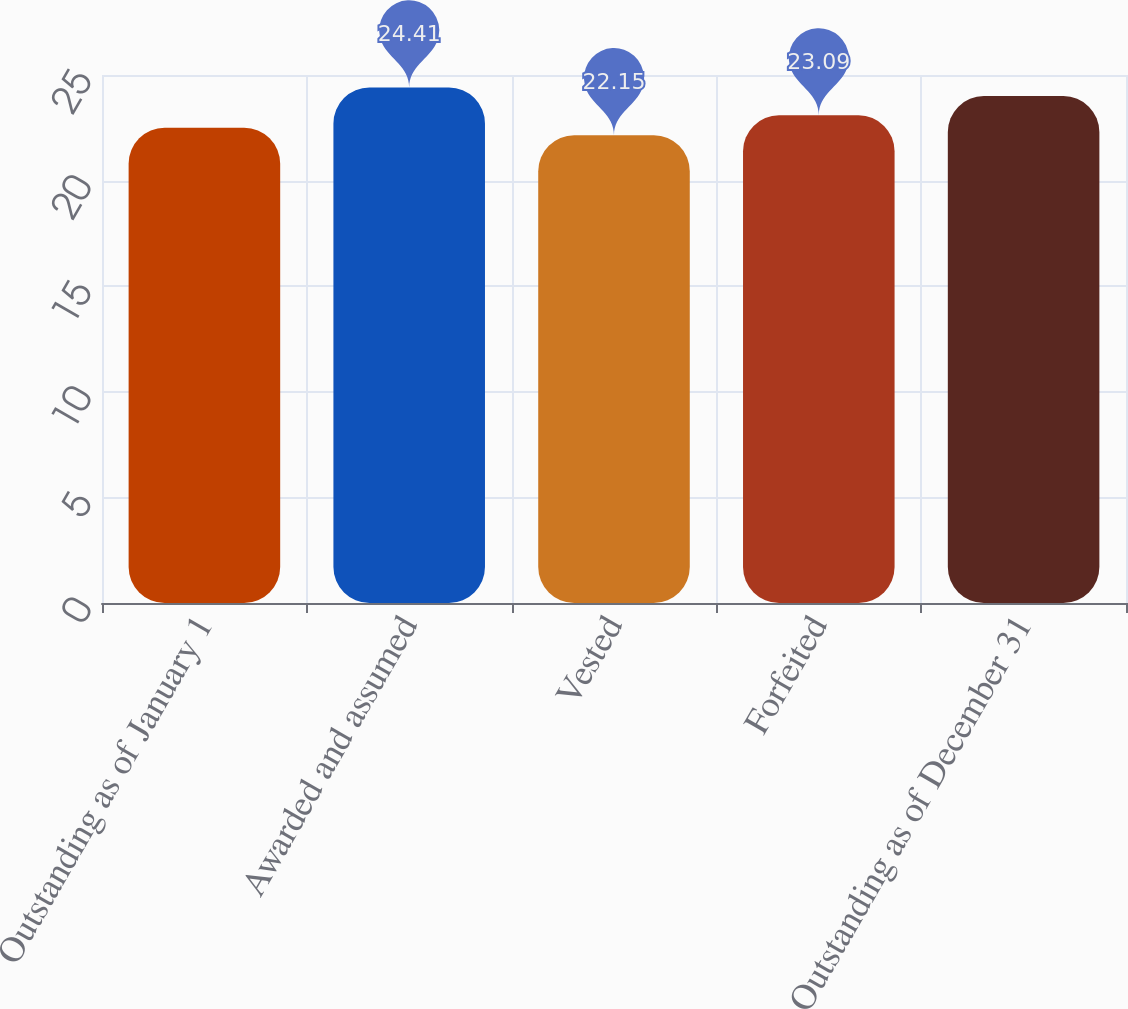<chart> <loc_0><loc_0><loc_500><loc_500><bar_chart><fcel>Outstanding as of January 1<fcel>Awarded and assumed<fcel>Vested<fcel>Forfeited<fcel>Outstanding as of December 31<nl><fcel>22.5<fcel>24.41<fcel>22.15<fcel>23.09<fcel>24<nl></chart> 